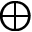Convert formula to latex. <formula><loc_0><loc_0><loc_500><loc_500>\oplus</formula> 